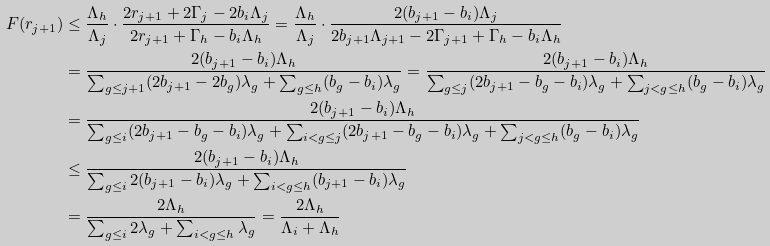Convert formula to latex. <formula><loc_0><loc_0><loc_500><loc_500>F ( r _ { j + 1 } ) & \leq \frac { \Lambda _ { h } } { \Lambda _ { j } } \cdot \frac { 2 r _ { j + 1 } + 2 \Gamma _ { j } - 2 b _ { i } \Lambda _ { j } } { 2 r _ { j + 1 } + \Gamma _ { h } - b _ { i } \Lambda _ { h } } = \frac { \Lambda _ { h } } { \Lambda _ { j } } \cdot \frac { 2 ( b _ { j + 1 } - b _ { i } ) \Lambda _ { j } } { 2 b _ { j + 1 } \Lambda _ { j + 1 } - 2 \Gamma _ { j + 1 } + \Gamma _ { h } - b _ { i } \Lambda _ { h } } \\ & = \frac { 2 ( b _ { j + 1 } - b _ { i } ) \Lambda _ { h } } { \sum _ { g \leq j + 1 } ( 2 b _ { j + 1 } - 2 b _ { g } ) \lambda _ { g } + \sum _ { g \leq h } ( b _ { g } - b _ { i } ) \lambda _ { g } } = \frac { 2 ( b _ { j + 1 } - b _ { i } ) \Lambda _ { h } } { \sum _ { g \leq j } ( 2 b _ { j + 1 } - b _ { g } - b _ { i } ) \lambda _ { g } + \sum _ { j < g \leq h } ( b _ { g } - b _ { i } ) \lambda _ { g } } \\ & = \frac { 2 ( b _ { j + 1 } - b _ { i } ) \Lambda _ { h } } { \sum _ { g \leq i } ( 2 b _ { j + 1 } - b _ { g } - b _ { i } ) \lambda _ { g } + \sum _ { i < g \leq j } ( 2 b _ { j + 1 } - b _ { g } - b _ { i } ) \lambda _ { g } + \sum _ { j < g \leq h } ( b _ { g } - b _ { i } ) \lambda _ { g } } \\ & \leq \frac { 2 ( b _ { j + 1 } - b _ { i } ) \Lambda _ { h } } { \sum _ { g \leq i } 2 ( b _ { j + 1 } - b _ { i } ) \lambda _ { g } + \sum _ { i < g \leq h } ( b _ { j + 1 } - b _ { i } ) \lambda _ { g } } \\ & = \frac { 2 \Lambda _ { h } } { \sum _ { g \leq i } 2 \lambda _ { g } + \sum _ { i < g \leq h } \lambda _ { g } } = \frac { 2 \Lambda _ { h } } { \Lambda _ { i } + \Lambda _ { h } }</formula> 